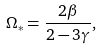Convert formula to latex. <formula><loc_0><loc_0><loc_500><loc_500>\Omega _ { * } = \frac { 2 \beta } { 2 - 3 \gamma } ,</formula> 